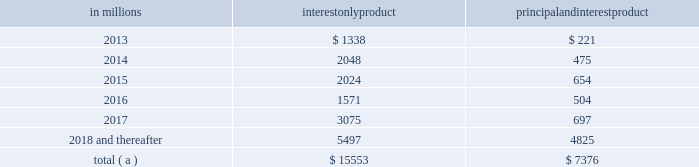Consist of first and second liens , the charge-off amounts for the pool are proportionate to the composition of first and second liens in the pool .
Our experience has been that the ratio of first to second lien loans has been consistent over time and is appropriately represented in our pools used for roll-rate calculations .
Generally , our variable-rate home equity lines of credit have either a seven or ten year draw period , followed by a 20 year amortization term .
During the draw period , we have home equity lines of credit where borrowers pay interest only and home equity lines of credit where borrowers pay principal and interest .
Based upon outstanding balances at december 31 , 2012 , the table presents the periods when home equity lines of credit draw periods are scheduled to end .
Table 39 : home equity lines of credit 2013 draw period end in millions interest product principal interest product .
( a ) includes approximately $ 166 million , $ 208 million , $ 213 million , $ 61 million , $ 70 million and $ 526 million of home equity lines of credit with balloon payments with draw periods scheduled to end in 2013 , 2014 , 2015 , 2016 , 2017 and 2018 and thereafter , respectively .
We view home equity lines of credit where borrowers are paying principal and interest under the draw period as less risky than those where the borrowers are paying interest only , as these borrowers have a demonstrated ability to make some level of principal and interest payments .
Based upon outstanding balances , and excluding purchased impaired loans , at december 31 , 2012 , for home equity lines of credit for which the borrower can no longer draw ( e.g. , draw period has ended or borrowing privileges have been terminated ) , approximately 3.86% ( 3.86 % ) were 30-89 days past due and approximately 5.96% ( 5.96 % ) were greater than or equal to 90 days past due .
Generally , when a borrower becomes 60 days past due , we terminate borrowing privileges , and those privileges are not subsequently reinstated .
At that point , we continue our collection/recovery processes , which may include a loss mitigation loan modification resulting in a loan that is classified as a tdr .
See note 5 asset quality in the notes to consolidated financial statements in item 8 of this report for additional information .
Loan modifications and troubled debt restructurings consumer loan modifications we modify loans under government and pnc-developed programs based upon our commitment to help eligible homeowners and borrowers avoid foreclosure , where appropriate .
Initially , a borrower is evaluated for a modification under a government program .
If a borrower does not qualify under a government program , the borrower is then evaluated under a pnc program .
Our programs utilize both temporary and permanent modifications and typically reduce the interest rate , extend the term and/or defer principal .
Temporary and permanent modifications under programs involving a change to loan terms are generally classified as tdrs .
Further , certain payment plans and trial payment arrangements which do not include a contractual change to loan terms may be classified as tdrs .
Additional detail on tdrs is discussed below as well as in note 5 asset quality in the notes to consolidated financial statements in item 8 of this report .
A temporary modification , with a term between three and 60 months , involves a change in original loan terms for a period of time and reverts to a calculated exit rate for the remaining term of the loan as of a specific date .
A permanent modification , with a term greater than 60 months , is a modification in which the terms of the original loan are changed .
Permanent modifications primarily include the government-created home affordable modification program ( hamp ) or pnc-developed hamp-like modification programs .
For consumer loan programs , such as residential mortgages and home equity loans and lines , we will enter into a temporary modification when the borrower has indicated a temporary hardship and a willingness to bring current the delinquent loan balance .
Examples of this situation often include delinquency due to illness or death in the family , or a loss of employment .
Permanent modifications are entered into when it is confirmed that the borrower does not possess the income necessary to continue making loan payments at the current amount , but our expectation is that payments at lower amounts can be made .
Residential mortgage and home equity loans and lines have been modified with changes in terms for up to 60 months , although the majority involve periods of three to 24 months .
We also monitor the success rates and delinquency status of our loan modification programs to assess their effectiveness in serving our customers 2019 needs while mitigating credit losses .
The following tables provide the number of accounts and unpaid principal balance of modified consumer real estate related loans as well as the number of accounts and unpaid principal balance of modified loans that were 60 days or more past due as of six months , nine months , twelve months and fifteen months after the modification date .
The pnc financial services group , inc .
2013 form 10-k 91 .
In millions , what is the total of home equity lines of credit? 
Computations: (15553 + 7376)
Answer: 22929.0. Consist of first and second liens , the charge-off amounts for the pool are proportionate to the composition of first and second liens in the pool .
Our experience has been that the ratio of first to second lien loans has been consistent over time and is appropriately represented in our pools used for roll-rate calculations .
Generally , our variable-rate home equity lines of credit have either a seven or ten year draw period , followed by a 20 year amortization term .
During the draw period , we have home equity lines of credit where borrowers pay interest only and home equity lines of credit where borrowers pay principal and interest .
Based upon outstanding balances at december 31 , 2012 , the table presents the periods when home equity lines of credit draw periods are scheduled to end .
Table 39 : home equity lines of credit 2013 draw period end in millions interest product principal interest product .
( a ) includes approximately $ 166 million , $ 208 million , $ 213 million , $ 61 million , $ 70 million and $ 526 million of home equity lines of credit with balloon payments with draw periods scheduled to end in 2013 , 2014 , 2015 , 2016 , 2017 and 2018 and thereafter , respectively .
We view home equity lines of credit where borrowers are paying principal and interest under the draw period as less risky than those where the borrowers are paying interest only , as these borrowers have a demonstrated ability to make some level of principal and interest payments .
Based upon outstanding balances , and excluding purchased impaired loans , at december 31 , 2012 , for home equity lines of credit for which the borrower can no longer draw ( e.g. , draw period has ended or borrowing privileges have been terminated ) , approximately 3.86% ( 3.86 % ) were 30-89 days past due and approximately 5.96% ( 5.96 % ) were greater than or equal to 90 days past due .
Generally , when a borrower becomes 60 days past due , we terminate borrowing privileges , and those privileges are not subsequently reinstated .
At that point , we continue our collection/recovery processes , which may include a loss mitigation loan modification resulting in a loan that is classified as a tdr .
See note 5 asset quality in the notes to consolidated financial statements in item 8 of this report for additional information .
Loan modifications and troubled debt restructurings consumer loan modifications we modify loans under government and pnc-developed programs based upon our commitment to help eligible homeowners and borrowers avoid foreclosure , where appropriate .
Initially , a borrower is evaluated for a modification under a government program .
If a borrower does not qualify under a government program , the borrower is then evaluated under a pnc program .
Our programs utilize both temporary and permanent modifications and typically reduce the interest rate , extend the term and/or defer principal .
Temporary and permanent modifications under programs involving a change to loan terms are generally classified as tdrs .
Further , certain payment plans and trial payment arrangements which do not include a contractual change to loan terms may be classified as tdrs .
Additional detail on tdrs is discussed below as well as in note 5 asset quality in the notes to consolidated financial statements in item 8 of this report .
A temporary modification , with a term between three and 60 months , involves a change in original loan terms for a period of time and reverts to a calculated exit rate for the remaining term of the loan as of a specific date .
A permanent modification , with a term greater than 60 months , is a modification in which the terms of the original loan are changed .
Permanent modifications primarily include the government-created home affordable modification program ( hamp ) or pnc-developed hamp-like modification programs .
For consumer loan programs , such as residential mortgages and home equity loans and lines , we will enter into a temporary modification when the borrower has indicated a temporary hardship and a willingness to bring current the delinquent loan balance .
Examples of this situation often include delinquency due to illness or death in the family , or a loss of employment .
Permanent modifications are entered into when it is confirmed that the borrower does not possess the income necessary to continue making loan payments at the current amount , but our expectation is that payments at lower amounts can be made .
Residential mortgage and home equity loans and lines have been modified with changes in terms for up to 60 months , although the majority involve periods of three to 24 months .
We also monitor the success rates and delinquency status of our loan modification programs to assess their effectiveness in serving our customers 2019 needs while mitigating credit losses .
The following tables provide the number of accounts and unpaid principal balance of modified consumer real estate related loans as well as the number of accounts and unpaid principal balance of modified loans that were 60 days or more past due as of six months , nine months , twelve months and fifteen months after the modification date .
The pnc financial services group , inc .
2013 form 10-k 91 .
What was the percent of the total of the interest only products home equity lines of credit draw periods are scheduled to end in 2017? 
Computations: (3075 / 15553)
Answer: 0.19771. Consist of first and second liens , the charge-off amounts for the pool are proportionate to the composition of first and second liens in the pool .
Our experience has been that the ratio of first to second lien loans has been consistent over time and is appropriately represented in our pools used for roll-rate calculations .
Generally , our variable-rate home equity lines of credit have either a seven or ten year draw period , followed by a 20 year amortization term .
During the draw period , we have home equity lines of credit where borrowers pay interest only and home equity lines of credit where borrowers pay principal and interest .
Based upon outstanding balances at december 31 , 2012 , the table presents the periods when home equity lines of credit draw periods are scheduled to end .
Table 39 : home equity lines of credit 2013 draw period end in millions interest product principal interest product .
( a ) includes approximately $ 166 million , $ 208 million , $ 213 million , $ 61 million , $ 70 million and $ 526 million of home equity lines of credit with balloon payments with draw periods scheduled to end in 2013 , 2014 , 2015 , 2016 , 2017 and 2018 and thereafter , respectively .
We view home equity lines of credit where borrowers are paying principal and interest under the draw period as less risky than those where the borrowers are paying interest only , as these borrowers have a demonstrated ability to make some level of principal and interest payments .
Based upon outstanding balances , and excluding purchased impaired loans , at december 31 , 2012 , for home equity lines of credit for which the borrower can no longer draw ( e.g. , draw period has ended or borrowing privileges have been terminated ) , approximately 3.86% ( 3.86 % ) were 30-89 days past due and approximately 5.96% ( 5.96 % ) were greater than or equal to 90 days past due .
Generally , when a borrower becomes 60 days past due , we terminate borrowing privileges , and those privileges are not subsequently reinstated .
At that point , we continue our collection/recovery processes , which may include a loss mitigation loan modification resulting in a loan that is classified as a tdr .
See note 5 asset quality in the notes to consolidated financial statements in item 8 of this report for additional information .
Loan modifications and troubled debt restructurings consumer loan modifications we modify loans under government and pnc-developed programs based upon our commitment to help eligible homeowners and borrowers avoid foreclosure , where appropriate .
Initially , a borrower is evaluated for a modification under a government program .
If a borrower does not qualify under a government program , the borrower is then evaluated under a pnc program .
Our programs utilize both temporary and permanent modifications and typically reduce the interest rate , extend the term and/or defer principal .
Temporary and permanent modifications under programs involving a change to loan terms are generally classified as tdrs .
Further , certain payment plans and trial payment arrangements which do not include a contractual change to loan terms may be classified as tdrs .
Additional detail on tdrs is discussed below as well as in note 5 asset quality in the notes to consolidated financial statements in item 8 of this report .
A temporary modification , with a term between three and 60 months , involves a change in original loan terms for a period of time and reverts to a calculated exit rate for the remaining term of the loan as of a specific date .
A permanent modification , with a term greater than 60 months , is a modification in which the terms of the original loan are changed .
Permanent modifications primarily include the government-created home affordable modification program ( hamp ) or pnc-developed hamp-like modification programs .
For consumer loan programs , such as residential mortgages and home equity loans and lines , we will enter into a temporary modification when the borrower has indicated a temporary hardship and a willingness to bring current the delinquent loan balance .
Examples of this situation often include delinquency due to illness or death in the family , or a loss of employment .
Permanent modifications are entered into when it is confirmed that the borrower does not possess the income necessary to continue making loan payments at the current amount , but our expectation is that payments at lower amounts can be made .
Residential mortgage and home equity loans and lines have been modified with changes in terms for up to 60 months , although the majority involve periods of three to 24 months .
We also monitor the success rates and delinquency status of our loan modification programs to assess their effectiveness in serving our customers 2019 needs while mitigating credit losses .
The following tables provide the number of accounts and unpaid principal balance of modified consumer real estate related loans as well as the number of accounts and unpaid principal balance of modified loans that were 60 days or more past due as of six months , nine months , twelve months and fifteen months after the modification date .
The pnc financial services group , inc .
2013 form 10-k 91 .
What is the average , in millions , of interest only product in 2013 , 2014 and 2015? 
Computations: (((1338 + 2048) + 2024) / 3)
Answer: 1803.33333. 